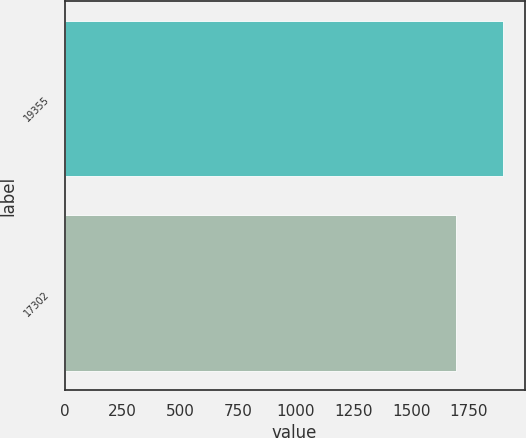Convert chart. <chart><loc_0><loc_0><loc_500><loc_500><bar_chart><fcel>19355<fcel>17302<nl><fcel>1896.4<fcel>1694.7<nl></chart> 